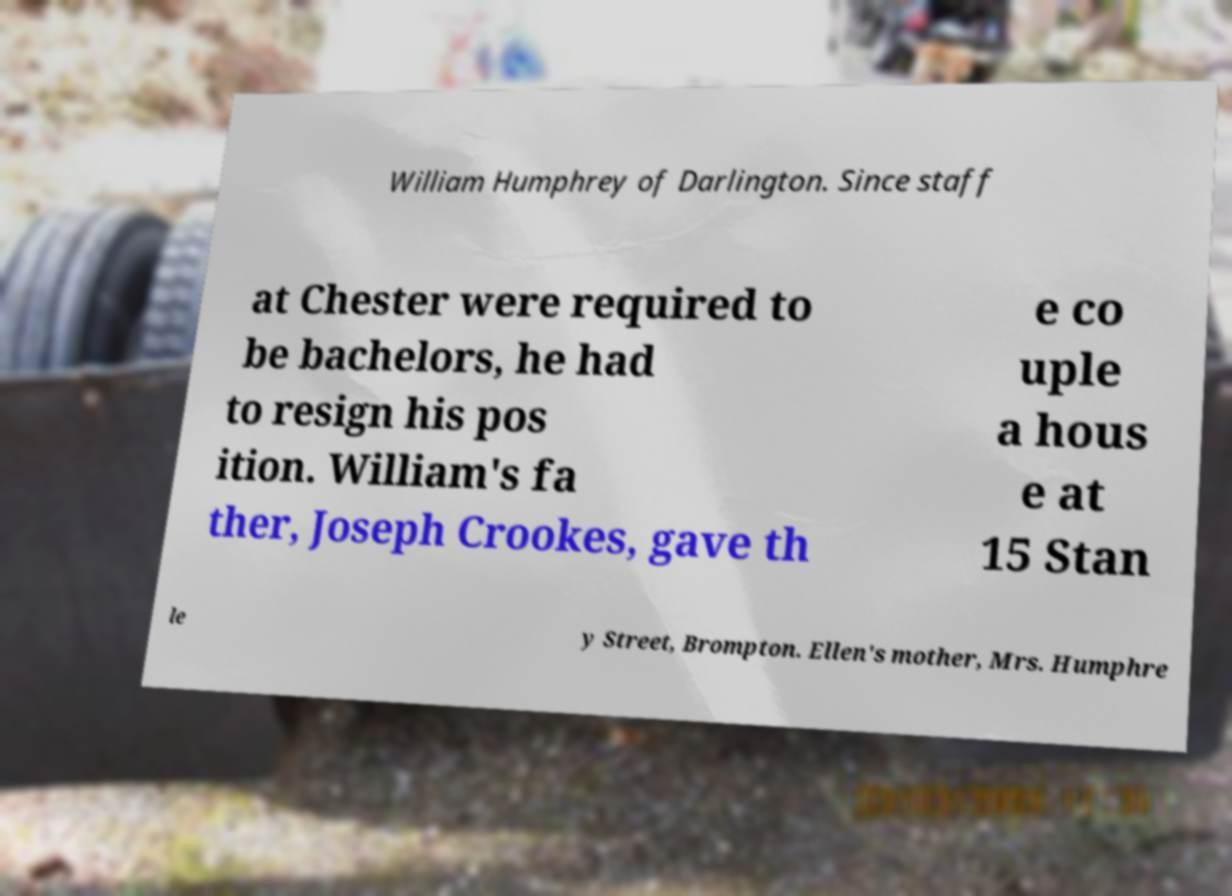Can you read and provide the text displayed in the image?This photo seems to have some interesting text. Can you extract and type it out for me? William Humphrey of Darlington. Since staff at Chester were required to be bachelors, he had to resign his pos ition. William's fa ther, Joseph Crookes, gave th e co uple a hous e at 15 Stan le y Street, Brompton. Ellen's mother, Mrs. Humphre 